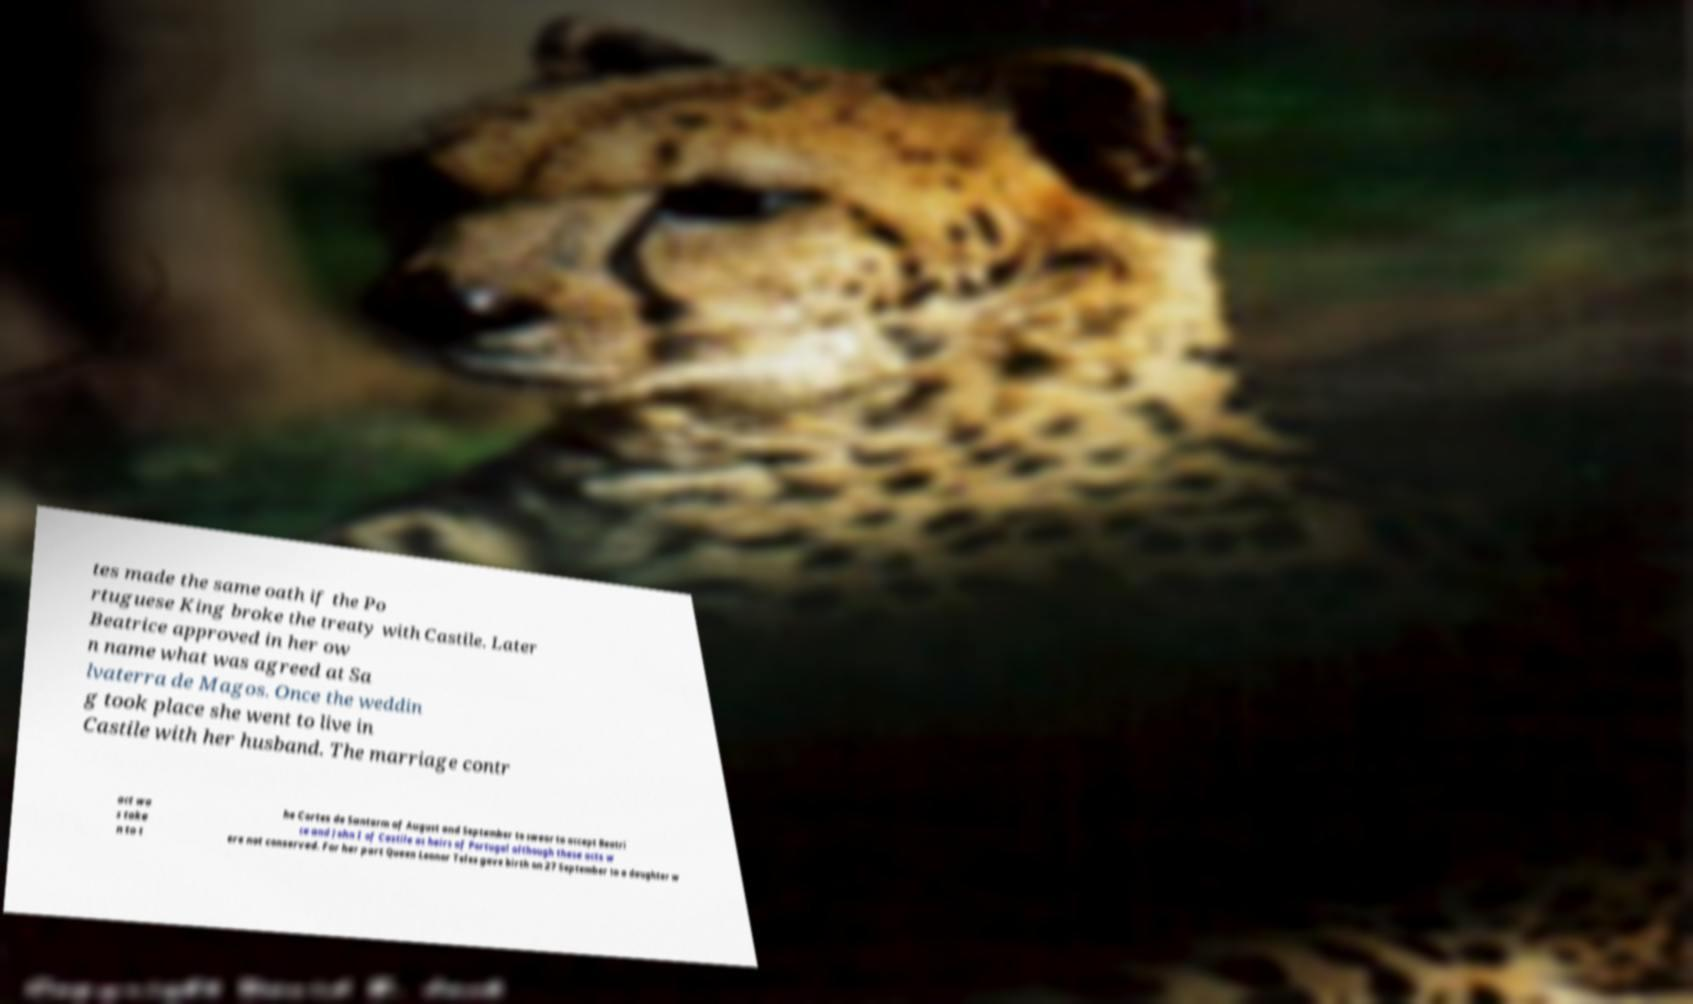For documentation purposes, I need the text within this image transcribed. Could you provide that? tes made the same oath if the Po rtuguese King broke the treaty with Castile. Later Beatrice approved in her ow n name what was agreed at Sa lvaterra de Magos. Once the weddin g took place she went to live in Castile with her husband. The marriage contr act wa s take n to t he Cortes de Santarm of August and September to swear to accept Beatri ce and John I of Castile as heirs of Portugal although these acts w ere not conserved. For her part Queen Leonor Teles gave birth on 27 September to a daughter w 